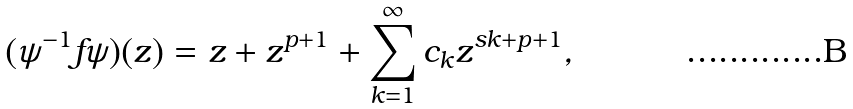<formula> <loc_0><loc_0><loc_500><loc_500>( \psi ^ { - 1 } f \psi ) ( z ) = z + z ^ { p + 1 } + \sum _ { k = 1 } ^ { \infty } c _ { k } z ^ { s k + p + 1 } ,</formula> 